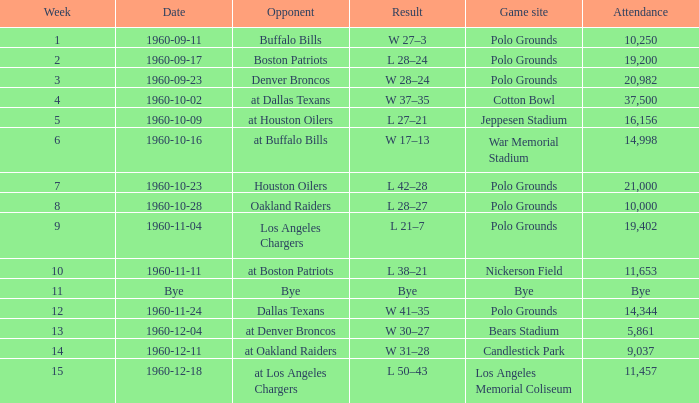What day was their game at candlestick park? 1960-12-11. 